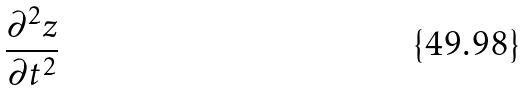Convert formula to latex. <formula><loc_0><loc_0><loc_500><loc_500>\frac { \partial ^ { 2 } z } { \partial t ^ { 2 } }</formula> 